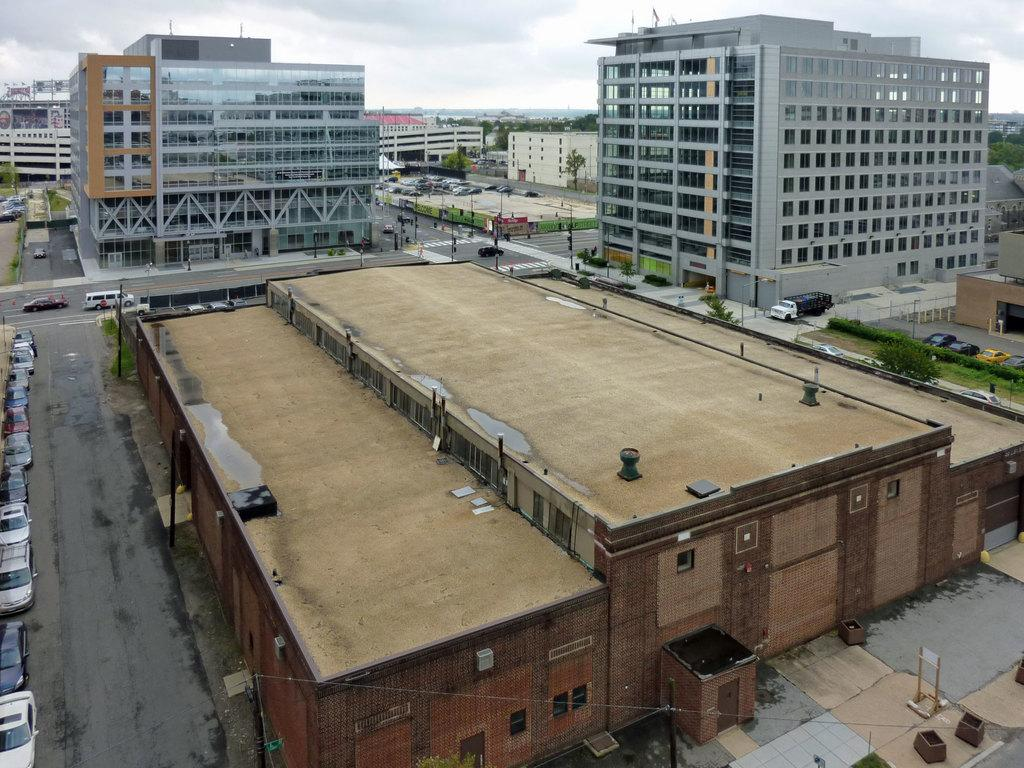What type of structures can be seen in the image? There are buildings in the image. What else is present in the image besides buildings? There are vehicles in the image. What can be seen in the background of the image? There are trees in the background of the image. What is the color of the trees in the image? The trees are green in color. What part of the natural environment is visible in the image? The sky is visible in the image. What is the color of the sky in the image? The sky is white in color. What type of love is being expressed by the trees in the image? There is no expression of love by the trees in the image, as trees do not have the ability to express emotions. 